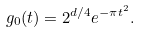<formula> <loc_0><loc_0><loc_500><loc_500>g _ { 0 } ( t ) = 2 ^ { d / 4 } e ^ { - \pi t ^ { 2 } } .</formula> 